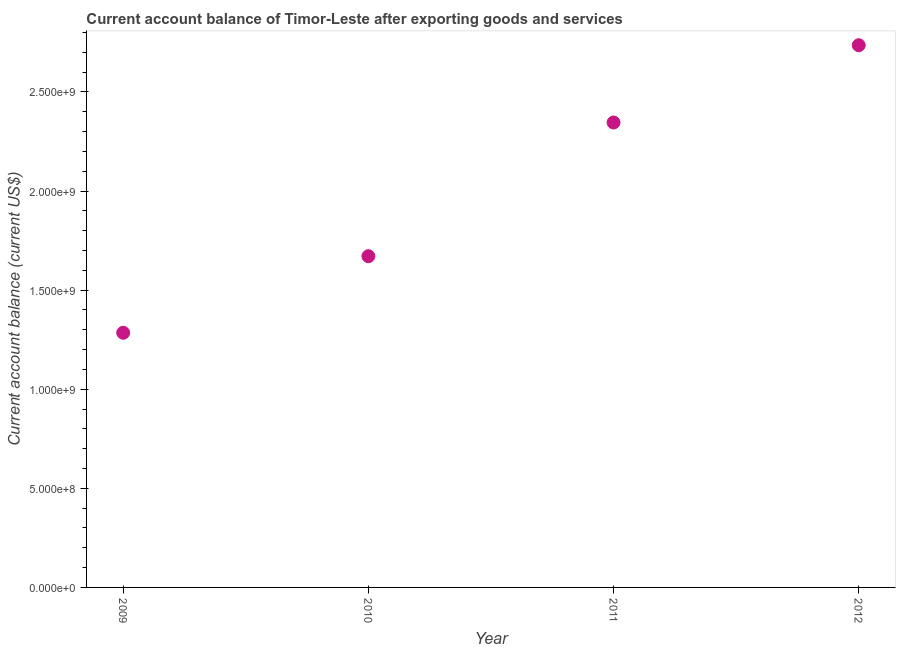What is the current account balance in 2011?
Your answer should be compact. 2.35e+09. Across all years, what is the maximum current account balance?
Ensure brevity in your answer.  2.74e+09. Across all years, what is the minimum current account balance?
Your answer should be very brief. 1.28e+09. In which year was the current account balance maximum?
Offer a very short reply. 2012. In which year was the current account balance minimum?
Your answer should be compact. 2009. What is the sum of the current account balance?
Offer a very short reply. 8.04e+09. What is the difference between the current account balance in 2011 and 2012?
Your response must be concise. -3.90e+08. What is the average current account balance per year?
Ensure brevity in your answer.  2.01e+09. What is the median current account balance?
Offer a terse response. 2.01e+09. Do a majority of the years between 2009 and 2012 (inclusive) have current account balance greater than 1900000000 US$?
Your answer should be compact. No. What is the ratio of the current account balance in 2010 to that in 2011?
Make the answer very short. 0.71. Is the current account balance in 2009 less than that in 2011?
Your response must be concise. Yes. What is the difference between the highest and the second highest current account balance?
Your response must be concise. 3.90e+08. Is the sum of the current account balance in 2009 and 2012 greater than the maximum current account balance across all years?
Your response must be concise. Yes. What is the difference between the highest and the lowest current account balance?
Keep it short and to the point. 1.45e+09. In how many years, is the current account balance greater than the average current account balance taken over all years?
Your answer should be compact. 2. Does the current account balance monotonically increase over the years?
Provide a succinct answer. Yes. How many dotlines are there?
Provide a short and direct response. 1. How many years are there in the graph?
Provide a succinct answer. 4. What is the difference between two consecutive major ticks on the Y-axis?
Provide a succinct answer. 5.00e+08. Does the graph contain any zero values?
Ensure brevity in your answer.  No. Does the graph contain grids?
Provide a short and direct response. No. What is the title of the graph?
Offer a very short reply. Current account balance of Timor-Leste after exporting goods and services. What is the label or title of the X-axis?
Your response must be concise. Year. What is the label or title of the Y-axis?
Make the answer very short. Current account balance (current US$). What is the Current account balance (current US$) in 2009?
Keep it short and to the point. 1.28e+09. What is the Current account balance (current US$) in 2010?
Ensure brevity in your answer.  1.67e+09. What is the Current account balance (current US$) in 2011?
Your answer should be very brief. 2.35e+09. What is the Current account balance (current US$) in 2012?
Make the answer very short. 2.74e+09. What is the difference between the Current account balance (current US$) in 2009 and 2010?
Your answer should be very brief. -3.86e+08. What is the difference between the Current account balance (current US$) in 2009 and 2011?
Keep it short and to the point. -1.06e+09. What is the difference between the Current account balance (current US$) in 2009 and 2012?
Ensure brevity in your answer.  -1.45e+09. What is the difference between the Current account balance (current US$) in 2010 and 2011?
Provide a succinct answer. -6.75e+08. What is the difference between the Current account balance (current US$) in 2010 and 2012?
Provide a succinct answer. -1.06e+09. What is the difference between the Current account balance (current US$) in 2011 and 2012?
Your answer should be very brief. -3.90e+08. What is the ratio of the Current account balance (current US$) in 2009 to that in 2010?
Offer a terse response. 0.77. What is the ratio of the Current account balance (current US$) in 2009 to that in 2011?
Your answer should be compact. 0.55. What is the ratio of the Current account balance (current US$) in 2009 to that in 2012?
Your answer should be compact. 0.47. What is the ratio of the Current account balance (current US$) in 2010 to that in 2011?
Offer a very short reply. 0.71. What is the ratio of the Current account balance (current US$) in 2010 to that in 2012?
Give a very brief answer. 0.61. What is the ratio of the Current account balance (current US$) in 2011 to that in 2012?
Provide a succinct answer. 0.86. 